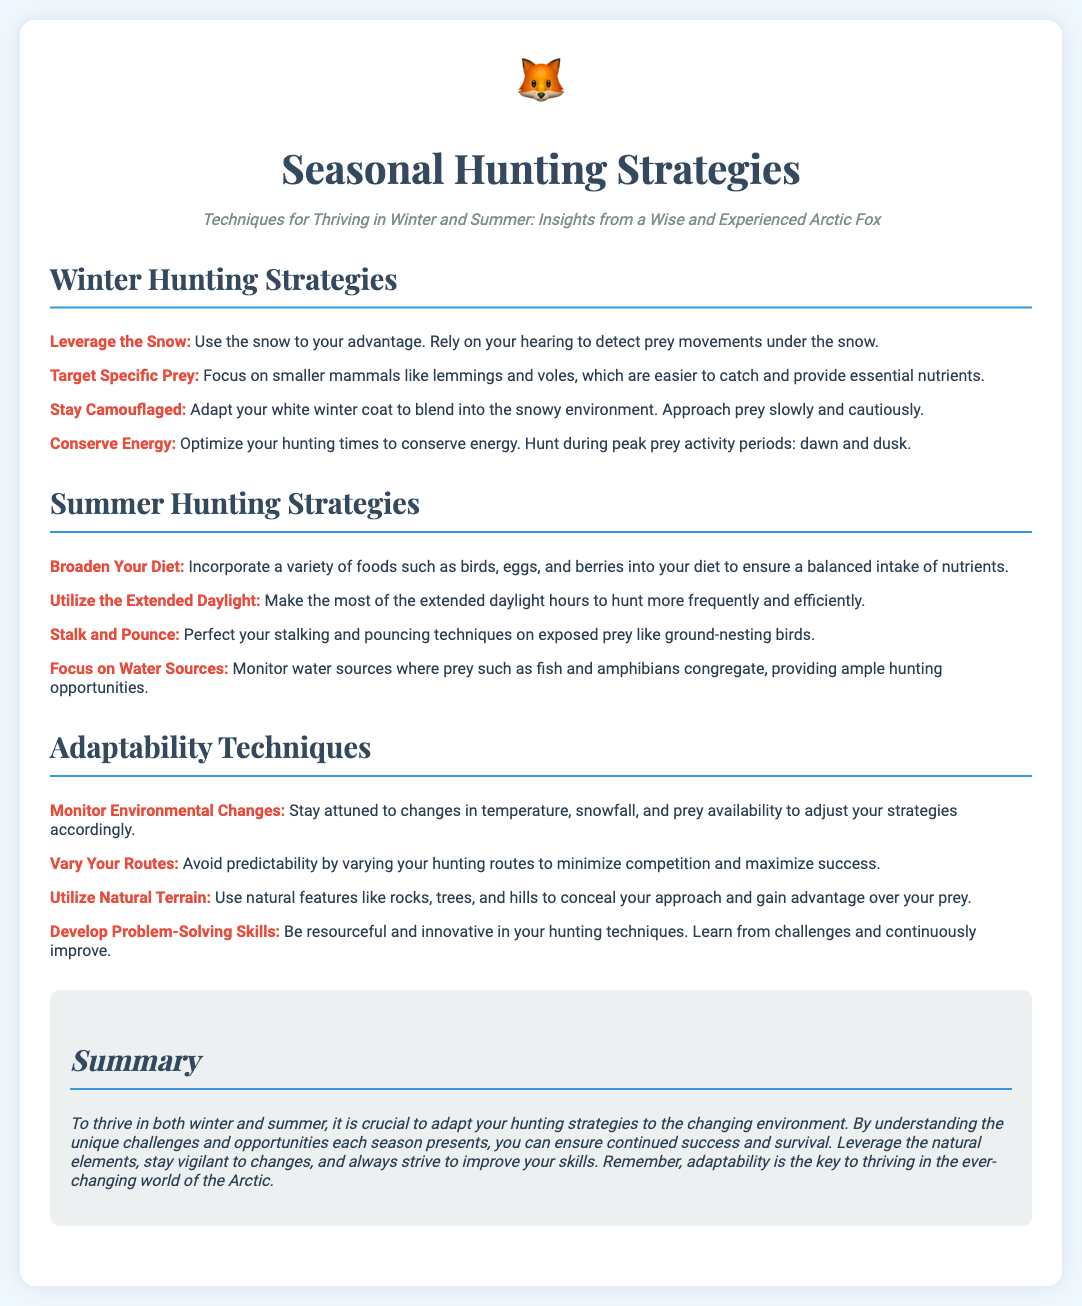What are the winter hunting strategies mentioned? The document lists specific winter hunting strategies such as leveraging snow, targeting specific prey, staying camouflaged, and conserving energy.
Answer: Leveraging the Snow, Target Specific Prey, Stay Camouflaged, Conserve Energy Which prey should be targeted in winter? The bullet point under winter strategies specifically mentions the focus on smaller mammals, which are easier to catch.
Answer: Smaller mammals What is a summer hunting strategy involving diet? One of the strategies in the summer section highlights the importance of incorporating various foods into one's diet.
Answer: Broaden Your Diet Which natural resource should be focused on for summer hunting? The document emphasizes monitoring water sources for hunting opportunities in summer.
Answer: Water sources What skill is essential for adaptability according to the document? The adaptability techniques section mentions problem-solving as a crucial skill for hunting.
Answer: Problem-Solving Skills How should hunting routes be managed? The document advises varying hunting routes to avoid predictability and enhance success.
Answer: Vary Your Routes What is the summary's main message? The summary encapsulates the need for adaptability in hunting strategies to thrive in changing environments.
Answer: Adaptability is the key to thriving in the ever-changing world of the Arctic 